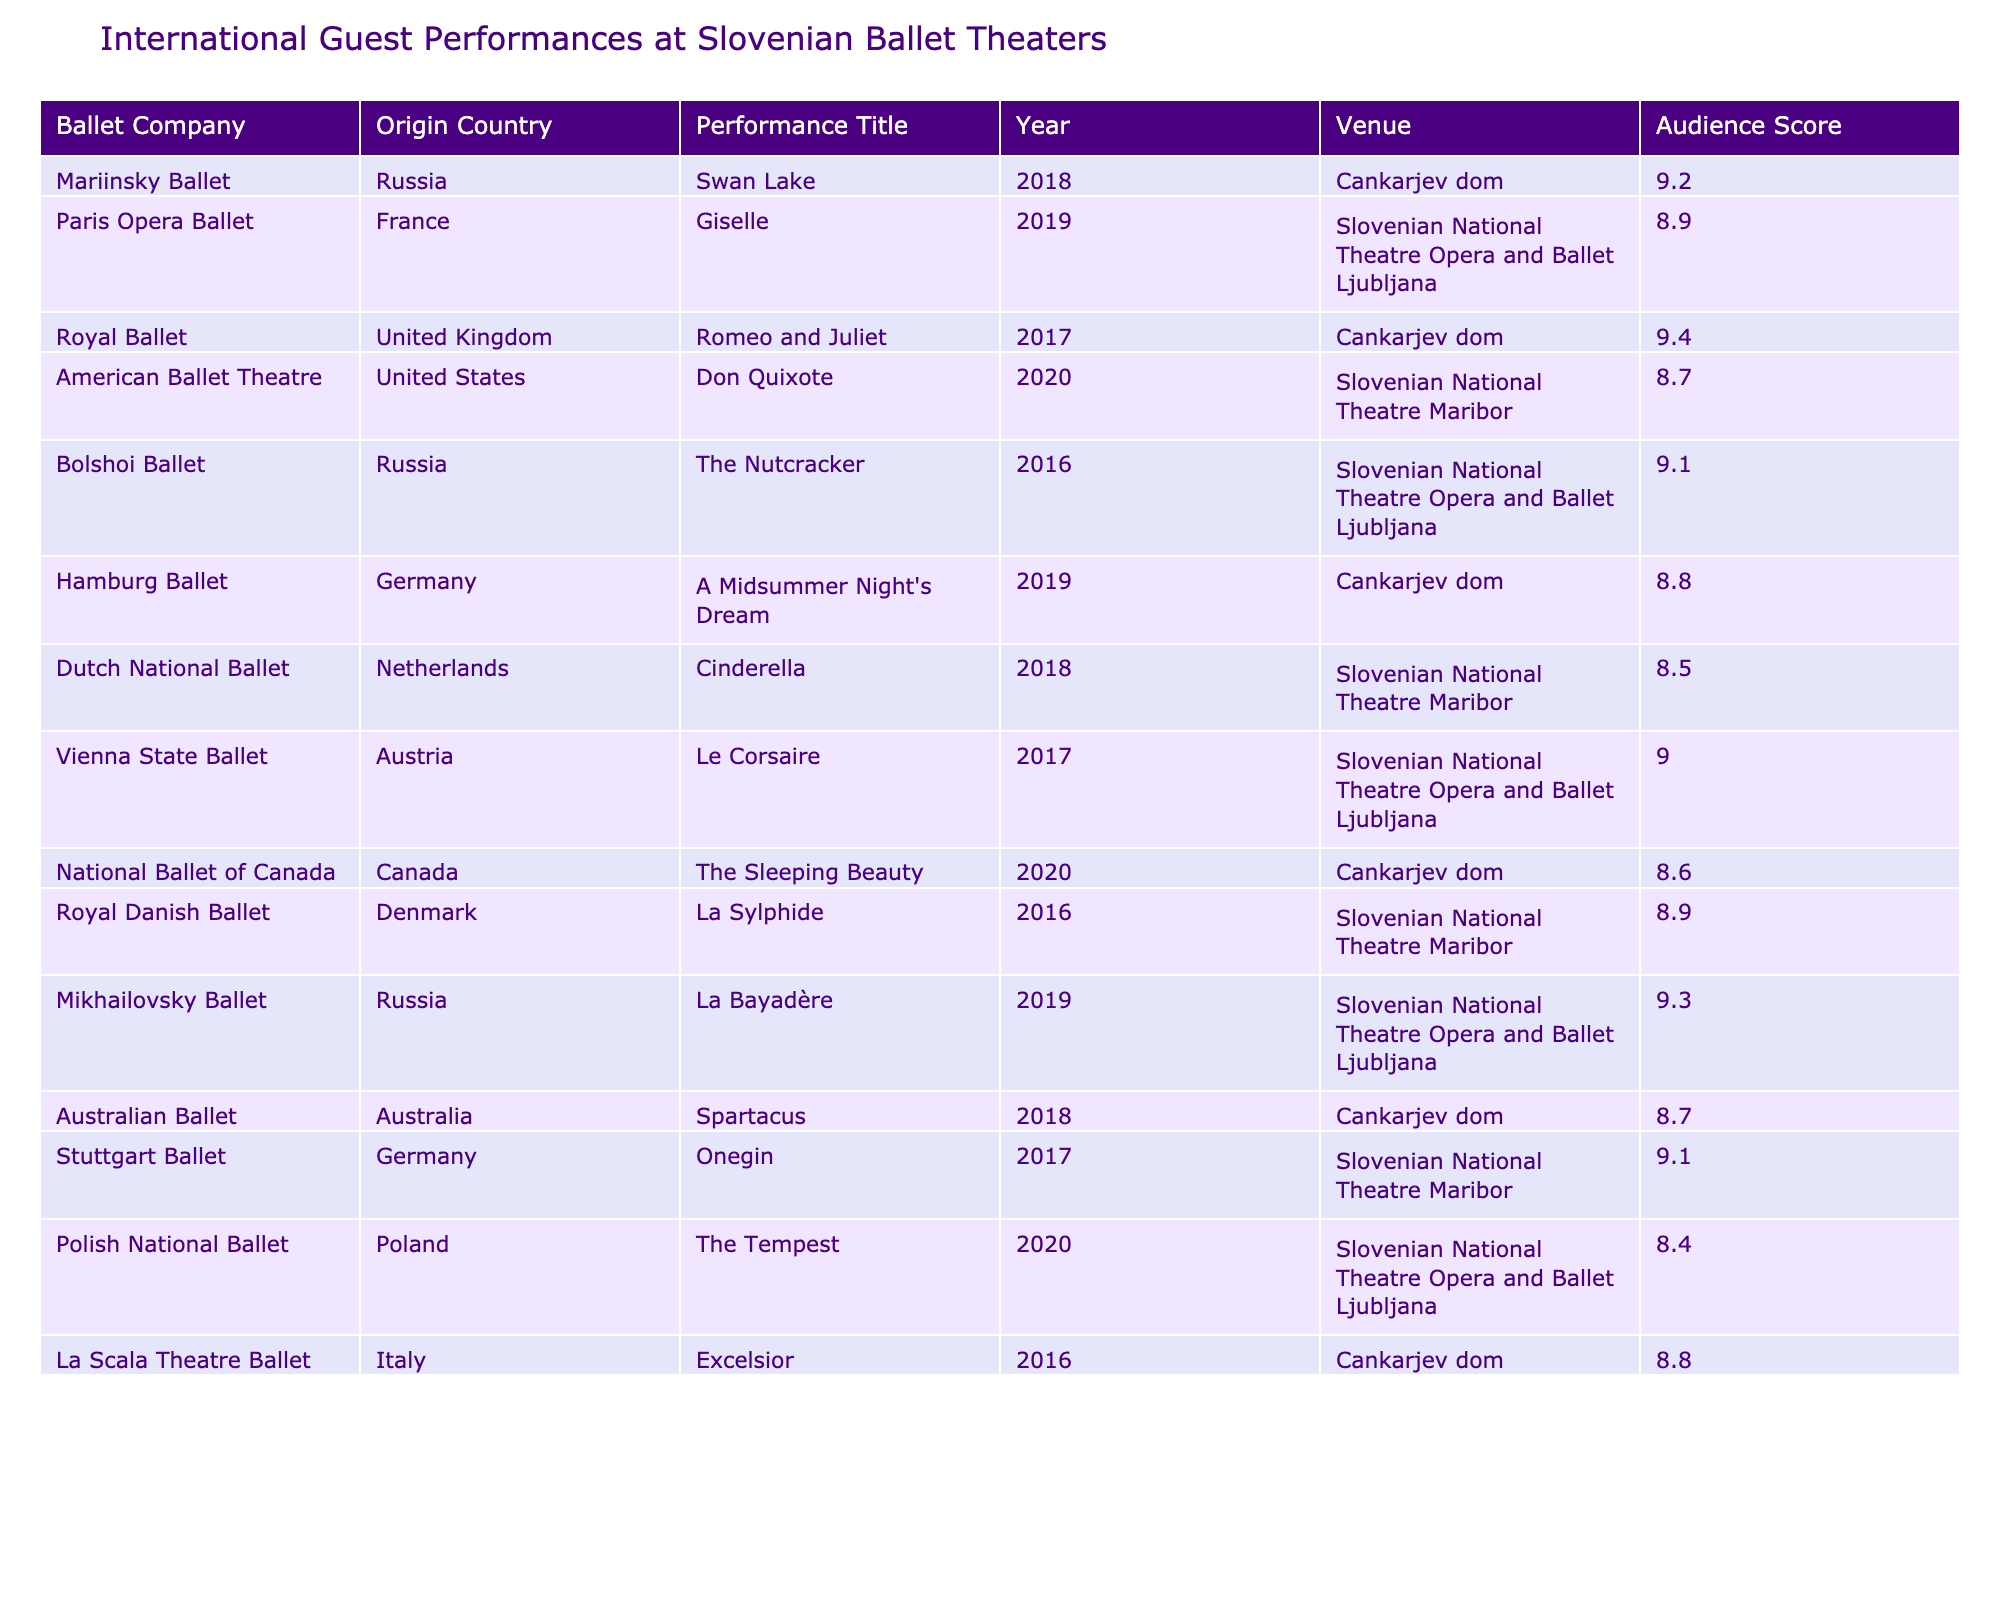What is the highest audience score recorded in the table? The table lists various performances along with their audience scores. By examining the scores, the highest score is 9.4, which is attributed to the Royal Ballet's performance of Romeo and Juliet in 2017.
Answer: 9.4 Which ballet company had a performance in 2019 that scored less than 9.0? From the table, the performances in 2019 are the Paris Opera Ballet with a score of 8.9 and the Hamburg Ballet with a score of 8.8. Both scores are below 9.0.
Answer: Paris Opera Ballet, Hamburg Ballet What is the average audience score for performances from Russian ballet companies? The Russian ballet companies listed are the Mariinsky Ballet (9.2), Bolshoi Ballet (9.1), and Mikhailovsky Ballet (9.3). Summing these scores gives 27.6, and dividing by 3 (the number of performances) gives an average of 9.2.
Answer: 9.2 Did any ballet performance in the table have an audience score of 8.4 or below? Checking the audience scores in the table reveals that the Polish National Ballet's performance of The Tempest scored 8.4, which meets the criteria.
Answer: Yes Which country's ballet company had the overall best-rated performance? The Royal Ballet from the United Kingdom achieved the highest audience score of 9.4 for Romeo and Juliet in 2017, making it the best-rated performance among all companies.
Answer: United Kingdom How many ballet performances in total were staged in the Slovenian National Theatre Maribor? Looking through the table, there are performances by the American Ballet Theatre (2020), Dutch National Ballet (2018), Royal Danish Ballet (2016), and Stuttgart Ballet (2017) listed, totaling 4 performances.
Answer: 4 Is there a performance from the Netherlands that scored higher than 8.5? According to the table, the Dutch National Ballet's Cinderella performance in 2018 scored 8.5. There are no performances from the Netherlands that scored higher than this.
Answer: No What is the difference between the highest and lowest audience scores in the table? The highest score is 9.4 from the Royal Ballet and the lowest score is 8.4 from the Polish National Ballet. The difference is 9.4 - 8.4 = 1.0.
Answer: 1.0 Which venue hosted the performance of La Sylphide and what was its audience score? The Royal Danish Ballet performed La Sylphide at the Slovenian National Theatre Maribor, receiving an audience score of 8.9.
Answer: Slovenian National Theatre Maribor, 8.9 Were there more performances from Russia or from the United States? There are 3 performances listed from Russia (Mariinsky, Bolshoi, and Mikhailovsky Ballet) and 1 from the United States (American Ballet Theatre). Therefore, there are more performances from Russia.
Answer: Russia 